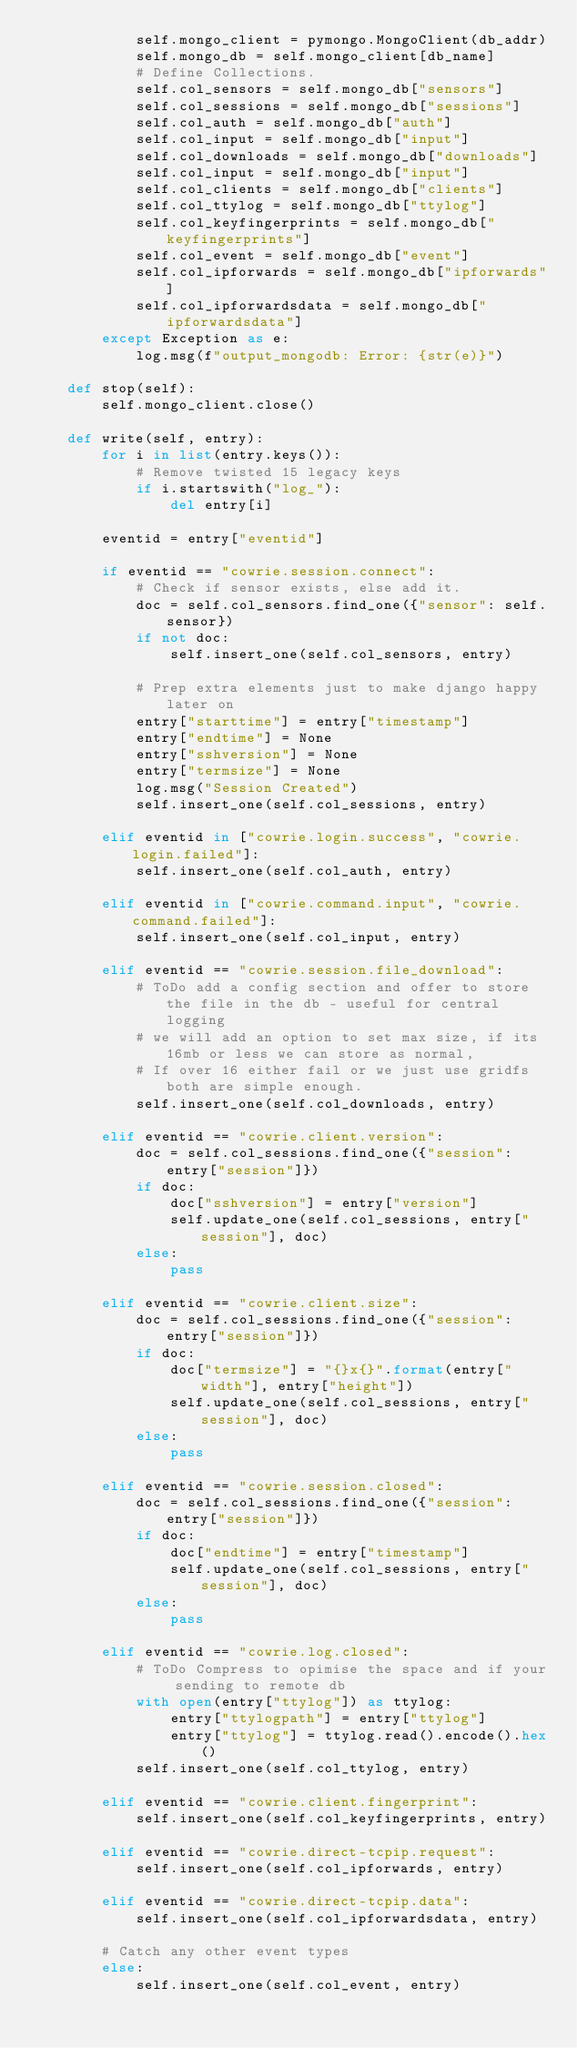<code> <loc_0><loc_0><loc_500><loc_500><_Python_>            self.mongo_client = pymongo.MongoClient(db_addr)
            self.mongo_db = self.mongo_client[db_name]
            # Define Collections.
            self.col_sensors = self.mongo_db["sensors"]
            self.col_sessions = self.mongo_db["sessions"]
            self.col_auth = self.mongo_db["auth"]
            self.col_input = self.mongo_db["input"]
            self.col_downloads = self.mongo_db["downloads"]
            self.col_input = self.mongo_db["input"]
            self.col_clients = self.mongo_db["clients"]
            self.col_ttylog = self.mongo_db["ttylog"]
            self.col_keyfingerprints = self.mongo_db["keyfingerprints"]
            self.col_event = self.mongo_db["event"]
            self.col_ipforwards = self.mongo_db["ipforwards"]
            self.col_ipforwardsdata = self.mongo_db["ipforwardsdata"]
        except Exception as e:
            log.msg(f"output_mongodb: Error: {str(e)}")

    def stop(self):
        self.mongo_client.close()

    def write(self, entry):
        for i in list(entry.keys()):
            # Remove twisted 15 legacy keys
            if i.startswith("log_"):
                del entry[i]

        eventid = entry["eventid"]

        if eventid == "cowrie.session.connect":
            # Check if sensor exists, else add it.
            doc = self.col_sensors.find_one({"sensor": self.sensor})
            if not doc:
                self.insert_one(self.col_sensors, entry)

            # Prep extra elements just to make django happy later on
            entry["starttime"] = entry["timestamp"]
            entry["endtime"] = None
            entry["sshversion"] = None
            entry["termsize"] = None
            log.msg("Session Created")
            self.insert_one(self.col_sessions, entry)

        elif eventid in ["cowrie.login.success", "cowrie.login.failed"]:
            self.insert_one(self.col_auth, entry)

        elif eventid in ["cowrie.command.input", "cowrie.command.failed"]:
            self.insert_one(self.col_input, entry)

        elif eventid == "cowrie.session.file_download":
            # ToDo add a config section and offer to store the file in the db - useful for central logging
            # we will add an option to set max size, if its 16mb or less we can store as normal,
            # If over 16 either fail or we just use gridfs both are simple enough.
            self.insert_one(self.col_downloads, entry)

        elif eventid == "cowrie.client.version":
            doc = self.col_sessions.find_one({"session": entry["session"]})
            if doc:
                doc["sshversion"] = entry["version"]
                self.update_one(self.col_sessions, entry["session"], doc)
            else:
                pass

        elif eventid == "cowrie.client.size":
            doc = self.col_sessions.find_one({"session": entry["session"]})
            if doc:
                doc["termsize"] = "{}x{}".format(entry["width"], entry["height"])
                self.update_one(self.col_sessions, entry["session"], doc)
            else:
                pass

        elif eventid == "cowrie.session.closed":
            doc = self.col_sessions.find_one({"session": entry["session"]})
            if doc:
                doc["endtime"] = entry["timestamp"]
                self.update_one(self.col_sessions, entry["session"], doc)
            else:
                pass

        elif eventid == "cowrie.log.closed":
            # ToDo Compress to opimise the space and if your sending to remote db
            with open(entry["ttylog"]) as ttylog:
                entry["ttylogpath"] = entry["ttylog"]
                entry["ttylog"] = ttylog.read().encode().hex()
            self.insert_one(self.col_ttylog, entry)

        elif eventid == "cowrie.client.fingerprint":
            self.insert_one(self.col_keyfingerprints, entry)

        elif eventid == "cowrie.direct-tcpip.request":
            self.insert_one(self.col_ipforwards, entry)

        elif eventid == "cowrie.direct-tcpip.data":
            self.insert_one(self.col_ipforwardsdata, entry)

        # Catch any other event types
        else:
            self.insert_one(self.col_event, entry)
</code> 